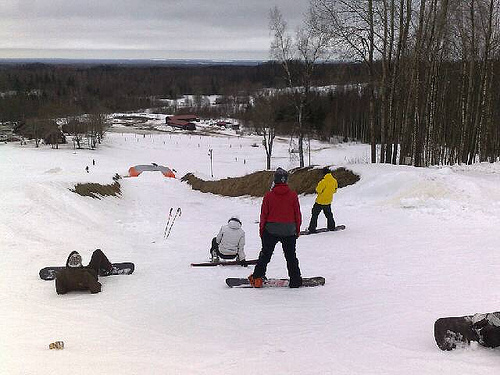<image>Which direction is the snowboarder moving? I am not sure in which direction the snowboarder is moving. It could be down, sideways, right, or forward. Is the person in the middle experienced at snowboarding? I don't know if the person in the middle is experienced at snowboarding. Which direction is the snowboarder moving? I don't know which direction the snowboarder is moving. It can be seen moving down, sideways, or forward. Is the person in the middle experienced at snowboarding? I am not sure if the person in the middle is experienced at snowboarding. It can be both yes or no. 